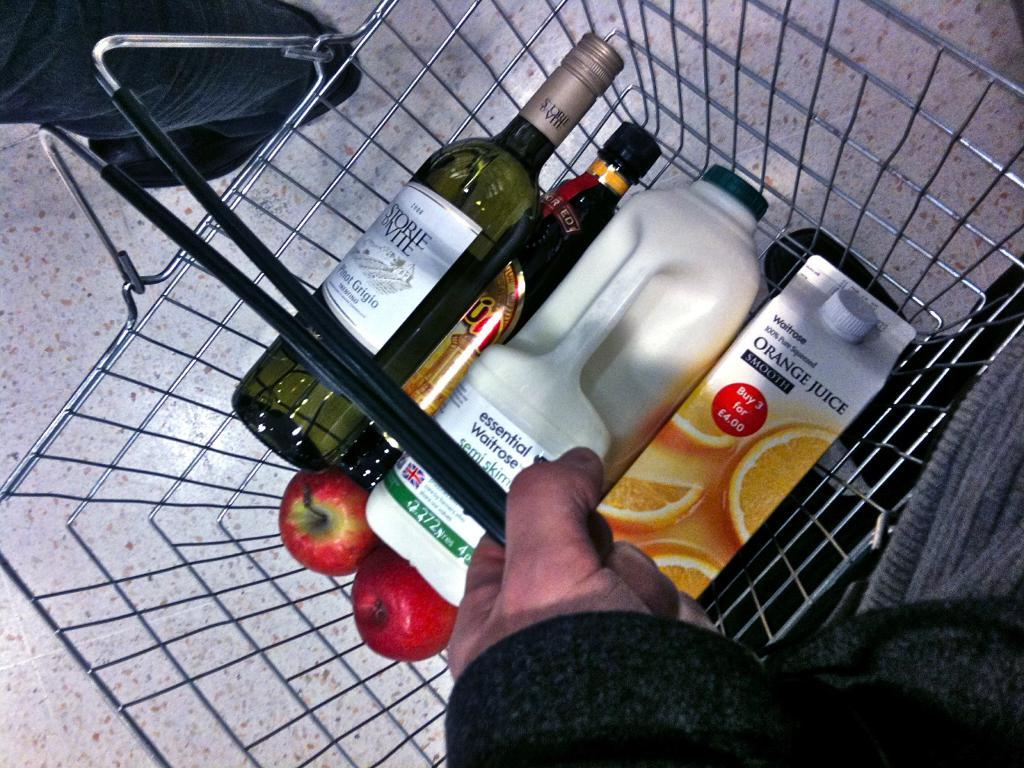<image>
Share a concise interpretation of the image provided. A market cart has milk and Orange Juice in it. 